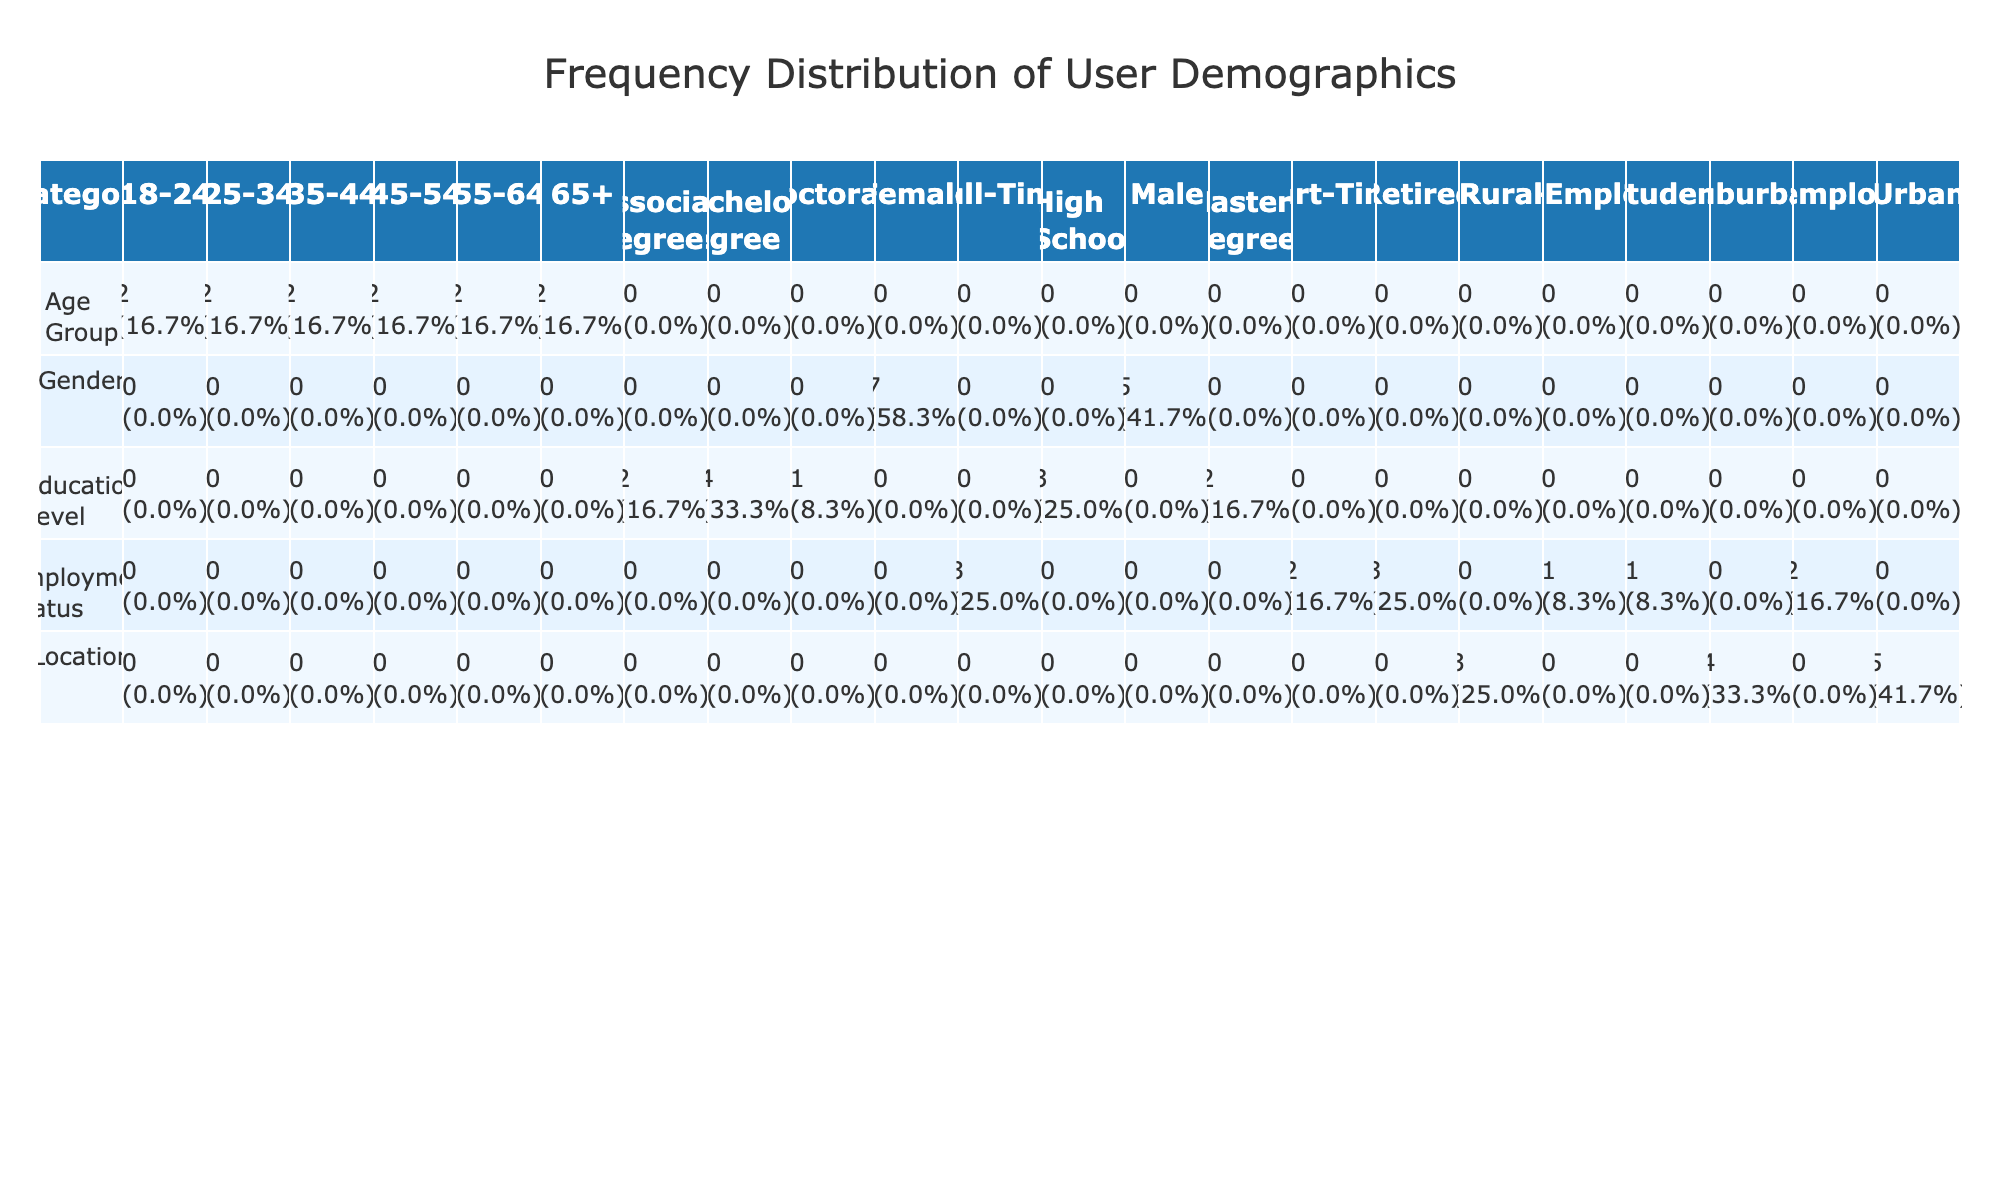What is the most common age group among the participants? The table provides frequency counts for each age group. By comparing the values in the corresponding row, we find that there are three entries for the age group 25-34, which is the highest number in that column compared to other age groups.
Answer: 25-34 How many participants are employed full-time? Referring to the Employment Status column, we can count the participants who are listed as Full-Time. From the data, there are four individuals categorized under Full-Time.
Answer: 4 Is the majority of participants located in urban areas? To determine if the majority is in urban locations, we count the entries in the Location column. There are five participants in Urban locations and four in Suburban and Rural combined, confirming that Urban has more participants than the others.
Answer: Yes What percentage of participants have a Master's Degree? From the Education Level column, there are two participants who have a Master's Degree. To find the percentage, we calculate (2/12) * 100 which is roughly 16.7%.
Answer: 16.7% Which gender has more participants in the age group 35-44 and what is their educational level? We check the rows for the age group 35-44. There are two participants in this age group: one Male with a Master’s Degree and one Female with a Doctorate. Therefore, the Female is the more represented gender, and their educational level is Doctorate.
Answer: Female, Doctorate How many participants have at least an Associate Degree? To answer this, we check the Education Level column for participants with Associate Degrees or higher. There are three participants with at least an Associate Degree: two with Bachelor's Degrees and one with a Doctorate. Summing these gives a total of five participants.
Answer: 5 What is the ratio of Male to Female participants in the retirement status? Searching the Employment Status for Retired, we find one Male and three Females who are retired. The ratio is therefore 1:3.
Answer: 1:3 What is the total number of participants from suburban areas with a Bachelor's Degree? By examining the row for Bachelor's Degree under the Location column specific to Suburban areas, we identify two individuals fitting this criterion, making the final count two.
Answer: 2 What age group has the lowest representation in this program? Reviewing the Age Group column, the group 65+ has the lowest number with only two participants compared to the others, which indicates it has the least representation among all age groups.
Answer: 65+ 